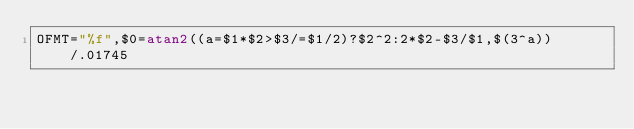<code> <loc_0><loc_0><loc_500><loc_500><_Awk_>OFMT="%f",$0=atan2((a=$1*$2>$3/=$1/2)?$2^2:2*$2-$3/$1,$(3^a))/.01745</code> 